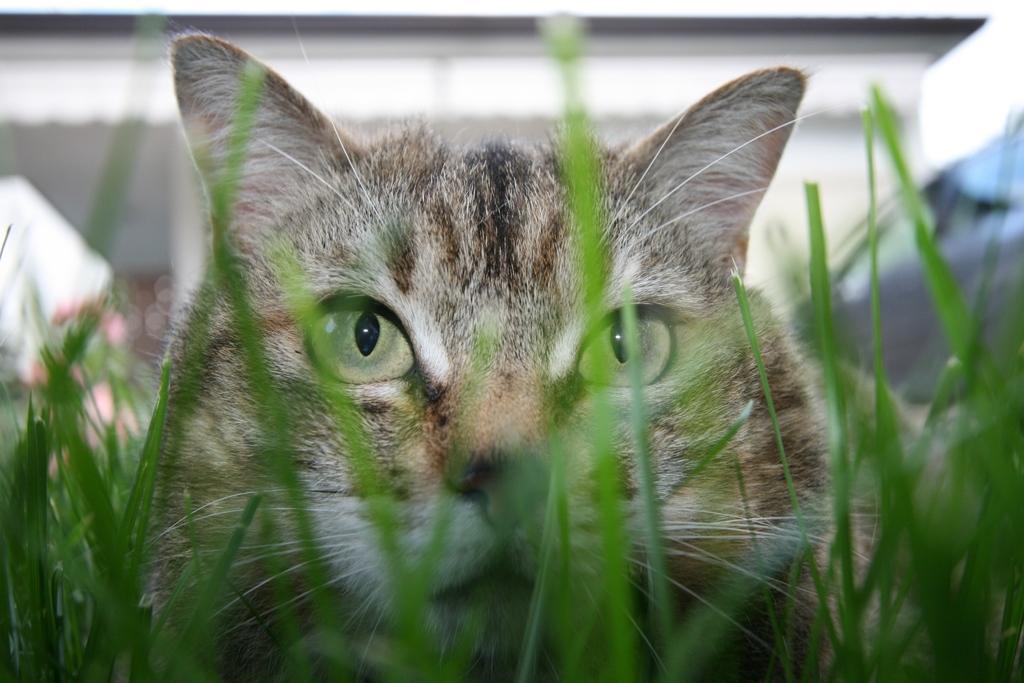In one or two sentences, can you explain what this image depicts? In this image I can see the grass which is green in color and I can see a cat which is cream, brown and black in color is in the grass. I can see the blurry background. 